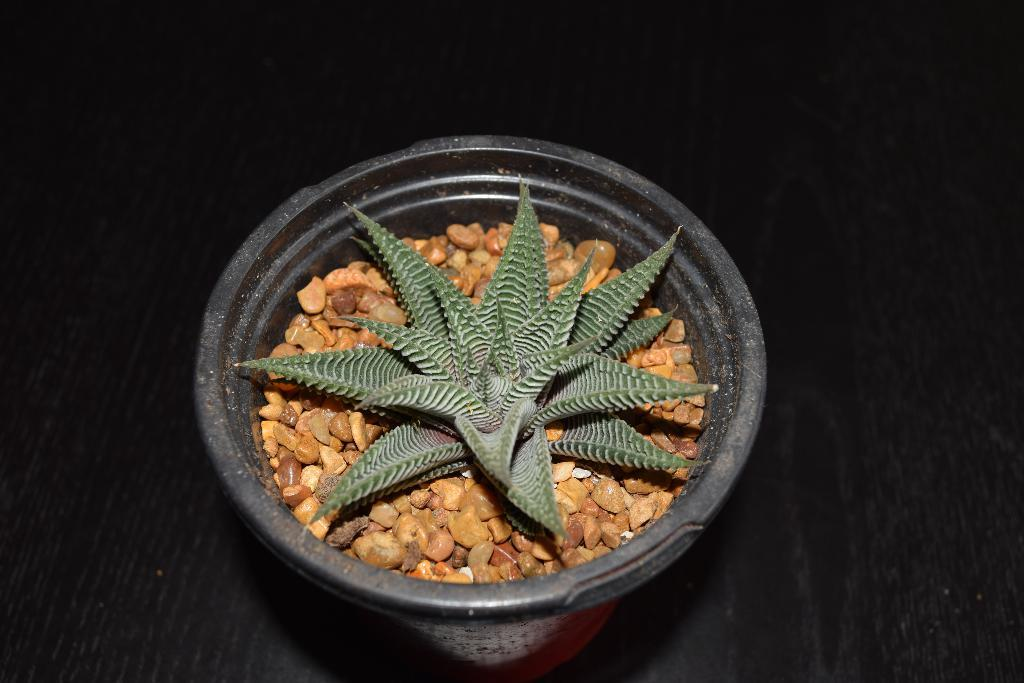What object is present in the image that is typically used for holding plants? There is a flower pot in the image. What type of material is present in the flower pot? Small stones are present in the flower pot. What type of plant can be seen in the flower pot? There is a small plant in the flower pot. What type of nerve can be seen connecting the small stones in the flower pot? There is no nerve present in the flower pot; it is a plant-related object. Can you describe the clouds visible in the image? There are no clouds visible in the image; it is focused on the flower pot. 